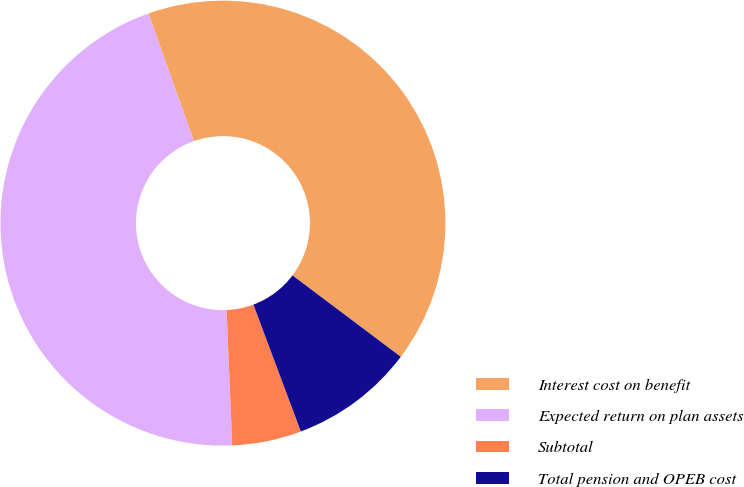<chart> <loc_0><loc_0><loc_500><loc_500><pie_chart><fcel>Interest cost on benefit<fcel>Expected return on plan assets<fcel>Subtotal<fcel>Total pension and OPEB cost<nl><fcel>40.7%<fcel>45.23%<fcel>5.03%<fcel>9.05%<nl></chart> 